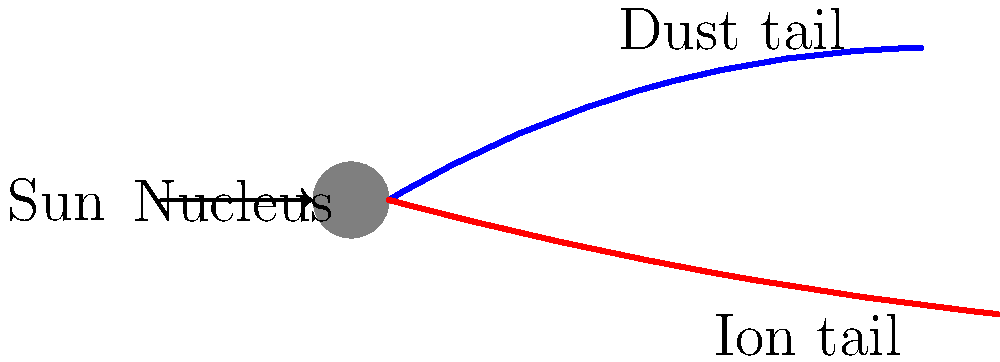As you plan your cosmic-themed fantasy draft party, you want to include some astronomy trivia. Looking at the diagram of a comet, why does the ion tail always point away from the Sun, while the dust tail curves? To understand why the ion and dust tails of a comet behave differently, let's break it down step-by-step:

1. Comet composition: A comet consists of a nucleus (made of ice, dust, and rock), surrounded by a coma (a fuzzy atmosphere of gas and dust).

2. Solar radiation effect: As a comet approaches the Sun, solar radiation causes the icy material to sublimate, releasing gas and dust particles.

3. Ion tail formation:
   a) Solar ultraviolet radiation ionizes some of the gas molecules.
   b) These ionized particles are electrically charged.
   c) The solar wind, a stream of charged particles from the Sun, interacts with these ions.
   d) The solar wind's magnetic field accelerates the ions, pushing them directly away from the Sun.
   e) This creates the straight, bluish ion tail always pointing away from the Sun.

4. Dust tail formation:
   a) Dust particles released from the comet are not electrically charged.
   b) They are affected primarily by solar radiation pressure and gravity.
   c) As the comet moves in its orbit, these particles lag behind, creating a curved tail.
   d) The dust tail appears yellowish due to reflected sunlight.

5. Tail directions:
   a) The ion tail always points directly away from the Sun due to the solar wind's influence.
   b) The dust tail curves because it's composed of particles following their own orbits around the Sun, influenced by both solar radiation pressure and gravity.

This difference in behavior between the ion and dust tails creates the distinctive dual-tail appearance of many comets.
Answer: Ion tail: charged particles affected by solar wind. Dust tail: neutral particles affected by radiation pressure and gravity. 